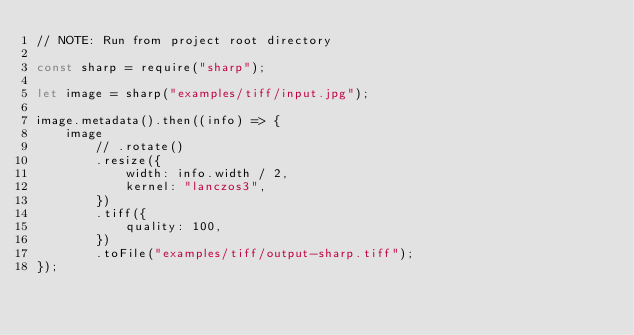Convert code to text. <code><loc_0><loc_0><loc_500><loc_500><_JavaScript_>// NOTE: Run from project root directory

const sharp = require("sharp");

let image = sharp("examples/tiff/input.jpg");

image.metadata().then((info) => {
	image
		// .rotate()
		.resize({
			width: info.width / 2,
			kernel: "lanczos3",
		})
		.tiff({
			quality: 100,
		})
		.toFile("examples/tiff/output-sharp.tiff");
});
</code> 